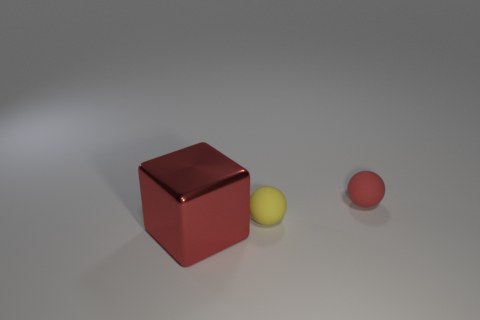Subtract all cubes. How many objects are left? 2 Add 1 tiny yellow rubber objects. How many tiny yellow rubber objects are left? 2 Add 1 small red spheres. How many small red spheres exist? 2 Add 3 large red cubes. How many objects exist? 6 Subtract all red balls. How many balls are left? 1 Subtract 1 red blocks. How many objects are left? 2 Subtract all purple spheres. Subtract all cyan blocks. How many spheres are left? 2 Subtract all yellow cubes. How many yellow spheres are left? 1 Subtract all small rubber objects. Subtract all small red matte objects. How many objects are left? 0 